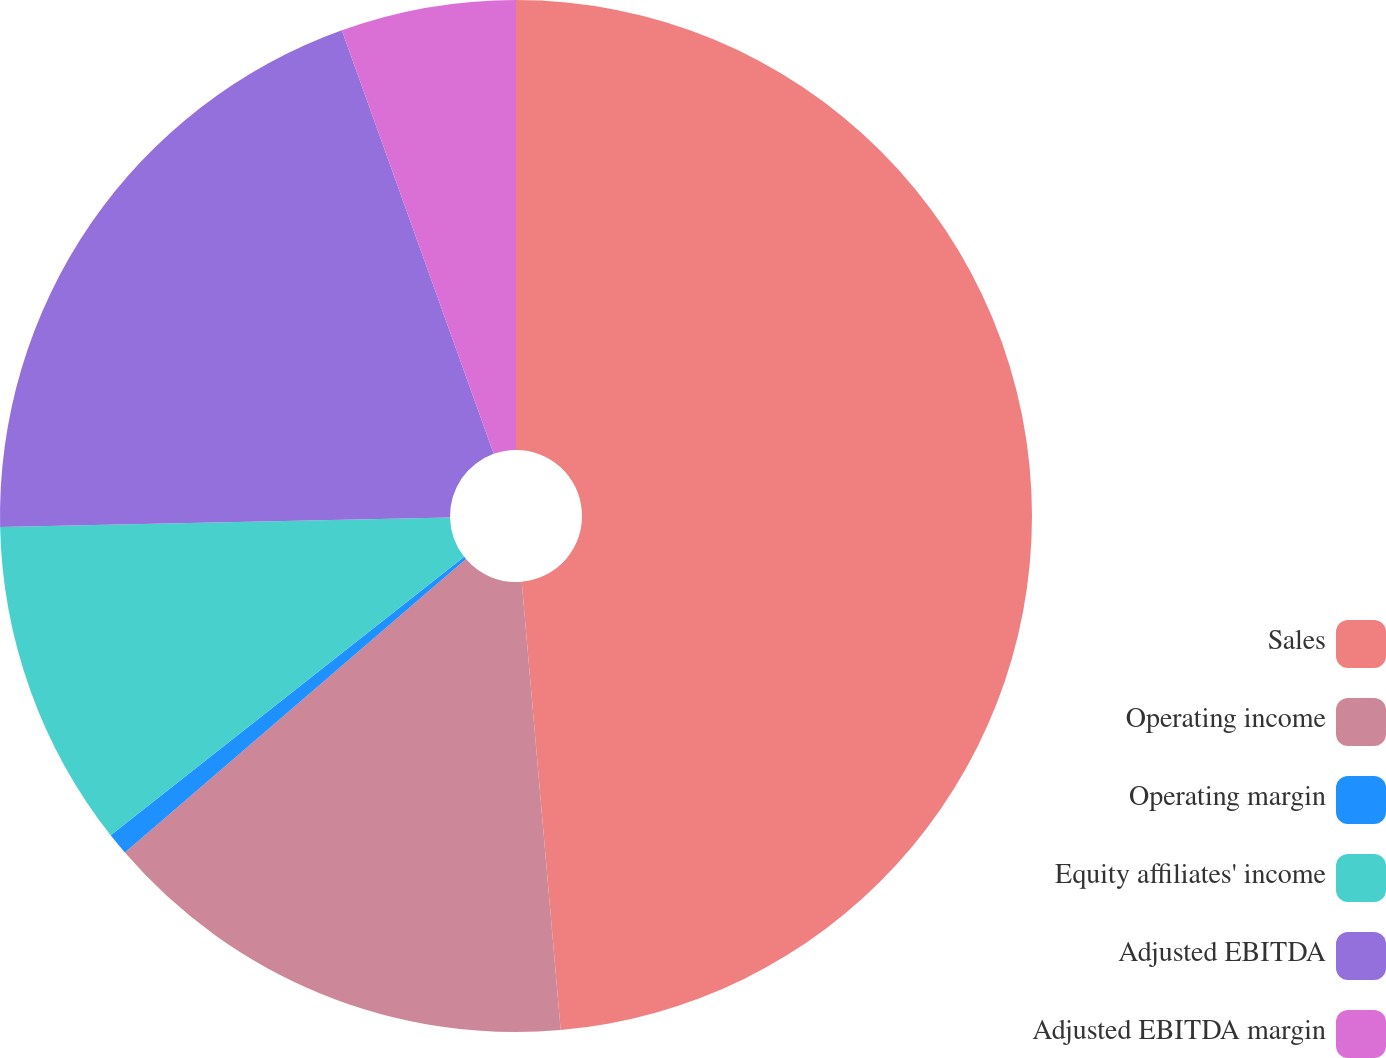<chart> <loc_0><loc_0><loc_500><loc_500><pie_chart><fcel>Sales<fcel>Operating income<fcel>Operating margin<fcel>Equity affiliates' income<fcel>Adjusted EBITDA<fcel>Adjusted EBITDA margin<nl><fcel>48.62%<fcel>15.07%<fcel>0.69%<fcel>10.28%<fcel>19.86%<fcel>5.48%<nl></chart> 